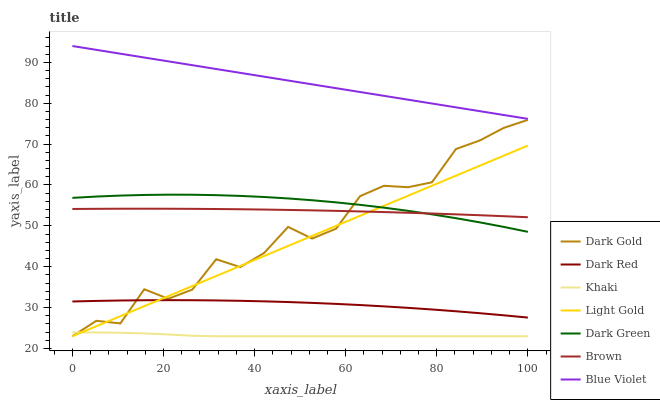Does Khaki have the minimum area under the curve?
Answer yes or no. Yes. Does Blue Violet have the maximum area under the curve?
Answer yes or no. Yes. Does Dark Gold have the minimum area under the curve?
Answer yes or no. No. Does Dark Gold have the maximum area under the curve?
Answer yes or no. No. Is Light Gold the smoothest?
Answer yes or no. Yes. Is Dark Gold the roughest?
Answer yes or no. Yes. Is Khaki the smoothest?
Answer yes or no. No. Is Khaki the roughest?
Answer yes or no. No. Does Khaki have the lowest value?
Answer yes or no. Yes. Does Dark Red have the lowest value?
Answer yes or no. No. Does Blue Violet have the highest value?
Answer yes or no. Yes. Does Dark Gold have the highest value?
Answer yes or no. No. Is Khaki less than Brown?
Answer yes or no. Yes. Is Dark Red greater than Khaki?
Answer yes or no. Yes. Does Dark Green intersect Light Gold?
Answer yes or no. Yes. Is Dark Green less than Light Gold?
Answer yes or no. No. Is Dark Green greater than Light Gold?
Answer yes or no. No. Does Khaki intersect Brown?
Answer yes or no. No. 